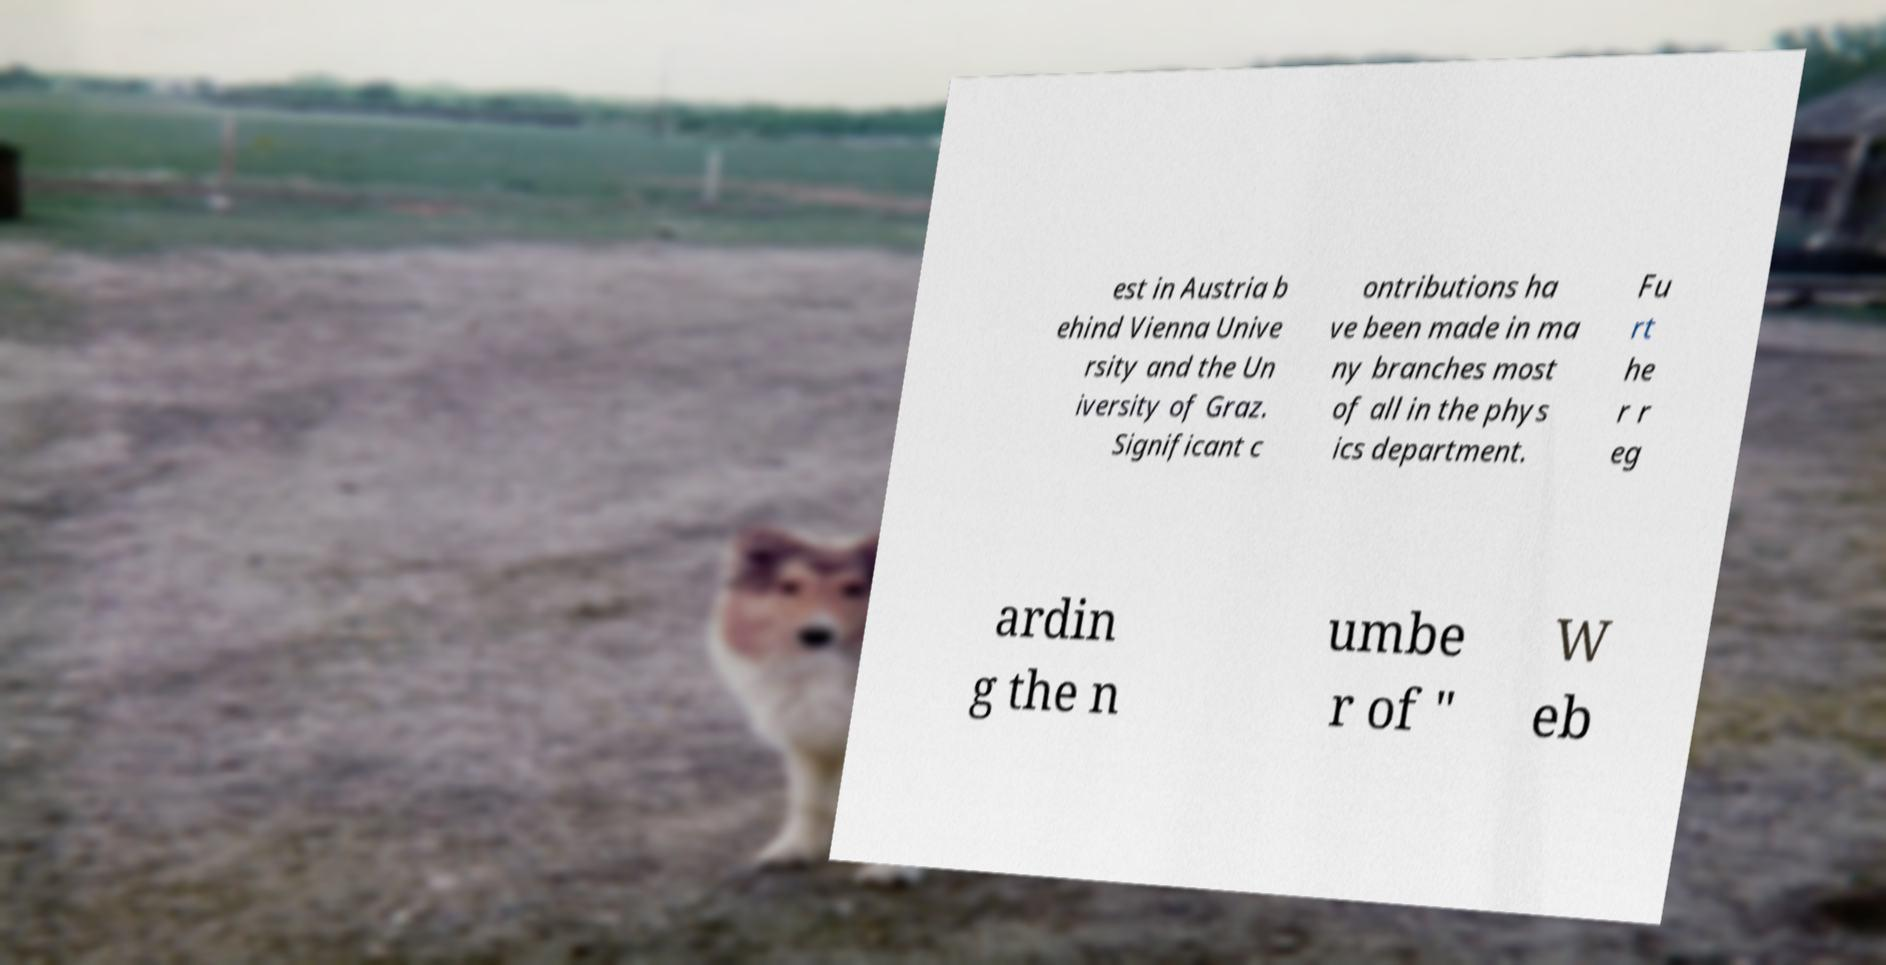Please identify and transcribe the text found in this image. est in Austria b ehind Vienna Unive rsity and the Un iversity of Graz. Significant c ontributions ha ve been made in ma ny branches most of all in the phys ics department. Fu rt he r r eg ardin g the n umbe r of " W eb 